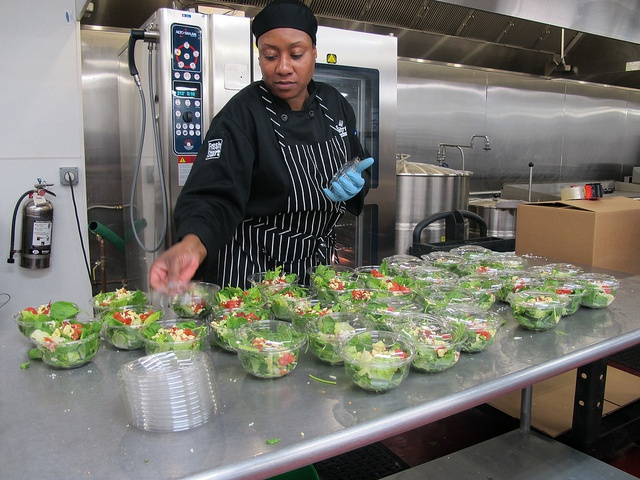Describe the objects in this image and their specific colors. I can see dining table in darkgray, gray, and olive tones, people in darkgray, black, gray, and brown tones, bowl in darkgray, gray, and olive tones, bowl in darkgray, olive, and gray tones, and bowl in darkgray, olive, and gray tones in this image. 